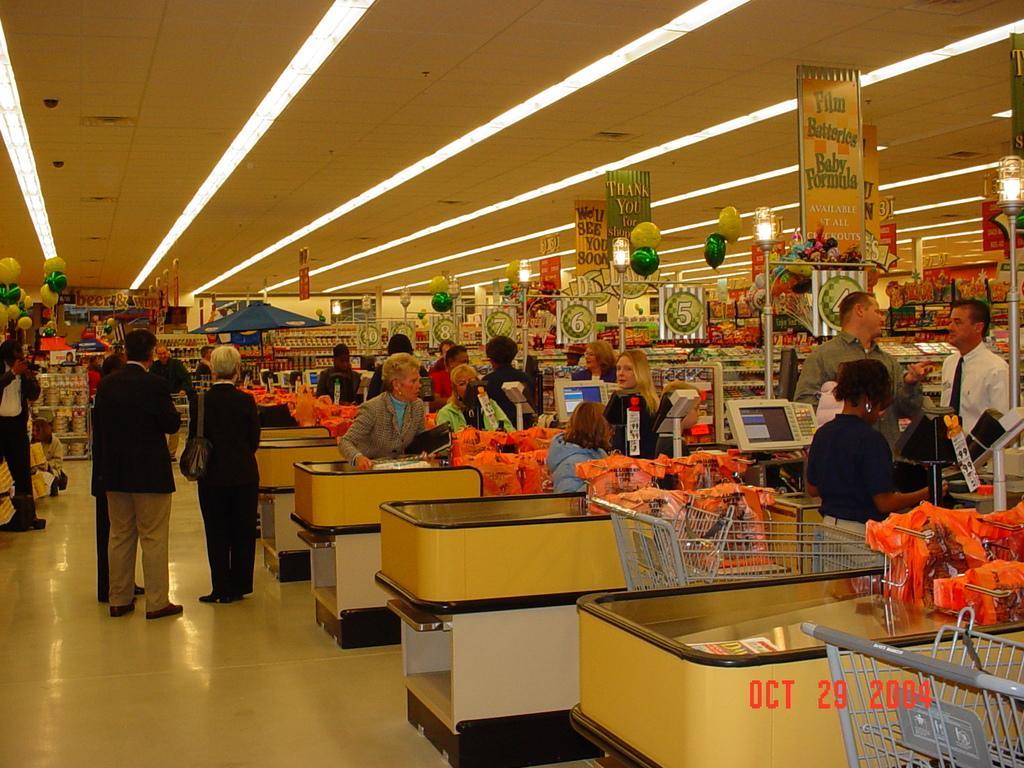Can you describe this image briefly? In this image we can see people, floor, carts, screens, racks, tables, boards, balloons, ceiling, lights, poles, and other objects. 